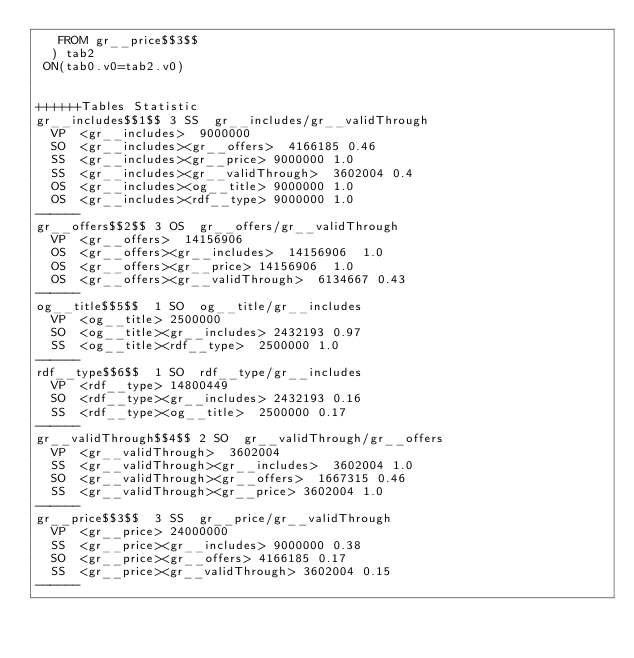Convert code to text. <code><loc_0><loc_0><loc_500><loc_500><_SQL_>	 FROM gr__price$$3$$
	) tab2
 ON(tab0.v0=tab2.v0)


++++++Tables Statistic
gr__includes$$1$$	3	SS	gr__includes/gr__validThrough
	VP	<gr__includes>	9000000
	SO	<gr__includes><gr__offers>	4166185	0.46
	SS	<gr__includes><gr__price>	9000000	1.0
	SS	<gr__includes><gr__validThrough>	3602004	0.4
	OS	<gr__includes><og__title>	9000000	1.0
	OS	<gr__includes><rdf__type>	9000000	1.0
------
gr__offers$$2$$	3	OS	gr__offers/gr__validThrough
	VP	<gr__offers>	14156906
	OS	<gr__offers><gr__includes>	14156906	1.0
	OS	<gr__offers><gr__price>	14156906	1.0
	OS	<gr__offers><gr__validThrough>	6134667	0.43
------
og__title$$5$$	1	SO	og__title/gr__includes
	VP	<og__title>	2500000
	SO	<og__title><gr__includes>	2432193	0.97
	SS	<og__title><rdf__type>	2500000	1.0
------
rdf__type$$6$$	1	SO	rdf__type/gr__includes
	VP	<rdf__type>	14800449
	SO	<rdf__type><gr__includes>	2432193	0.16
	SS	<rdf__type><og__title>	2500000	0.17
------
gr__validThrough$$4$$	2	SO	gr__validThrough/gr__offers
	VP	<gr__validThrough>	3602004
	SS	<gr__validThrough><gr__includes>	3602004	1.0
	SO	<gr__validThrough><gr__offers>	1667315	0.46
	SS	<gr__validThrough><gr__price>	3602004	1.0
------
gr__price$$3$$	3	SS	gr__price/gr__validThrough
	VP	<gr__price>	24000000
	SS	<gr__price><gr__includes>	9000000	0.38
	SO	<gr__price><gr__offers>	4166185	0.17
	SS	<gr__price><gr__validThrough>	3602004	0.15
------
</code> 